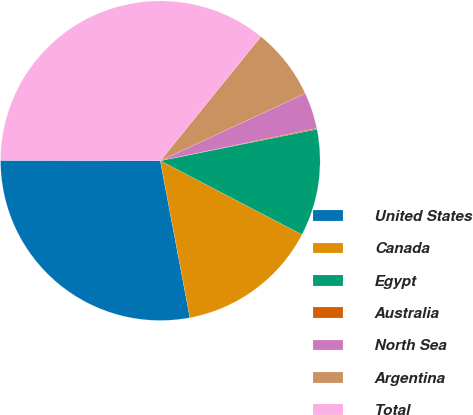Convert chart to OTSL. <chart><loc_0><loc_0><loc_500><loc_500><pie_chart><fcel>United States<fcel>Canada<fcel>Egypt<fcel>Australia<fcel>North Sea<fcel>Argentina<fcel>Total<nl><fcel>27.99%<fcel>14.38%<fcel>10.81%<fcel>0.1%<fcel>3.67%<fcel>7.24%<fcel>35.81%<nl></chart> 